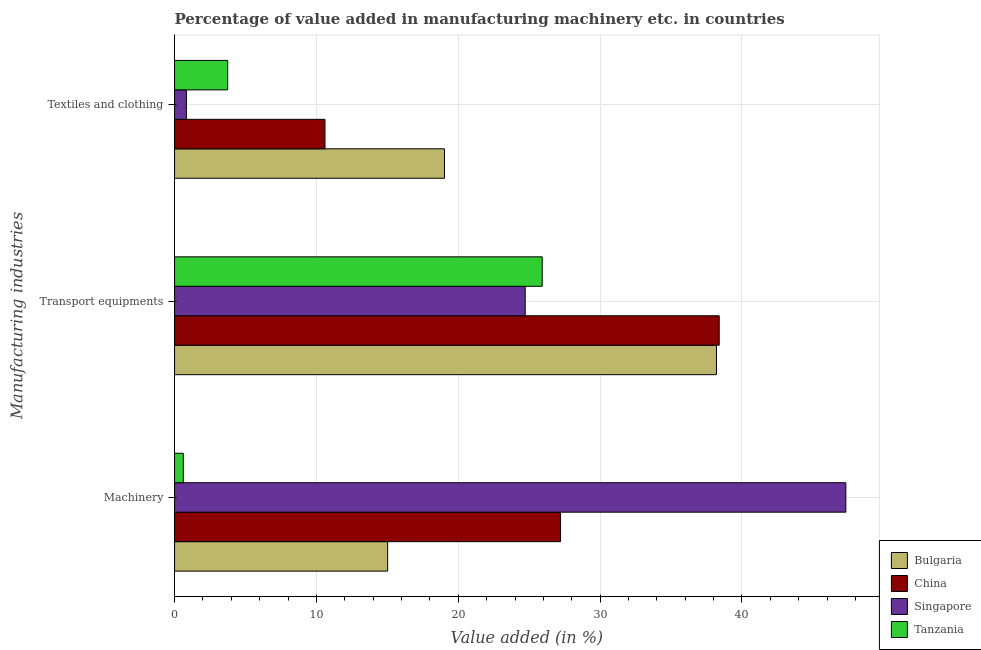How many different coloured bars are there?
Your response must be concise. 4. How many groups of bars are there?
Provide a succinct answer. 3. Are the number of bars per tick equal to the number of legend labels?
Provide a succinct answer. Yes. How many bars are there on the 2nd tick from the bottom?
Make the answer very short. 4. What is the label of the 1st group of bars from the top?
Make the answer very short. Textiles and clothing. What is the value added in manufacturing machinery in Singapore?
Your answer should be very brief. 47.32. Across all countries, what is the maximum value added in manufacturing machinery?
Give a very brief answer. 47.32. Across all countries, what is the minimum value added in manufacturing transport equipments?
Keep it short and to the point. 24.72. In which country was the value added in manufacturing machinery maximum?
Your response must be concise. Singapore. In which country was the value added in manufacturing transport equipments minimum?
Provide a succinct answer. Singapore. What is the total value added in manufacturing transport equipments in the graph?
Give a very brief answer. 127.24. What is the difference between the value added in manufacturing textile and clothing in Bulgaria and that in Singapore?
Offer a very short reply. 18.19. What is the difference between the value added in manufacturing transport equipments in China and the value added in manufacturing machinery in Singapore?
Provide a succinct answer. -8.93. What is the average value added in manufacturing machinery per country?
Provide a succinct answer. 22.54. What is the difference between the value added in manufacturing textile and clothing and value added in manufacturing machinery in Bulgaria?
Offer a terse response. 4.01. What is the ratio of the value added in manufacturing textile and clothing in Singapore to that in Tanzania?
Keep it short and to the point. 0.22. What is the difference between the highest and the second highest value added in manufacturing machinery?
Give a very brief answer. 20.11. What is the difference between the highest and the lowest value added in manufacturing transport equipments?
Ensure brevity in your answer.  13.68. In how many countries, is the value added in manufacturing textile and clothing greater than the average value added in manufacturing textile and clothing taken over all countries?
Make the answer very short. 2. What does the 1st bar from the top in Machinery represents?
Provide a short and direct response. Tanzania. What does the 3rd bar from the bottom in Textiles and clothing represents?
Ensure brevity in your answer.  Singapore. Is it the case that in every country, the sum of the value added in manufacturing machinery and value added in manufacturing transport equipments is greater than the value added in manufacturing textile and clothing?
Your answer should be compact. Yes. How many bars are there?
Make the answer very short. 12. How many countries are there in the graph?
Offer a terse response. 4. What is the difference between two consecutive major ticks on the X-axis?
Provide a succinct answer. 10. Are the values on the major ticks of X-axis written in scientific E-notation?
Ensure brevity in your answer.  No. Does the graph contain any zero values?
Offer a terse response. No. How are the legend labels stacked?
Offer a very short reply. Vertical. What is the title of the graph?
Offer a terse response. Percentage of value added in manufacturing machinery etc. in countries. What is the label or title of the X-axis?
Your response must be concise. Value added (in %). What is the label or title of the Y-axis?
Make the answer very short. Manufacturing industries. What is the Value added (in %) of Bulgaria in Machinery?
Offer a terse response. 15.02. What is the Value added (in %) of China in Machinery?
Your answer should be very brief. 27.21. What is the Value added (in %) of Singapore in Machinery?
Offer a very short reply. 47.32. What is the Value added (in %) in Tanzania in Machinery?
Make the answer very short. 0.62. What is the Value added (in %) of Bulgaria in Transport equipments?
Provide a succinct answer. 38.2. What is the Value added (in %) in China in Transport equipments?
Provide a succinct answer. 38.4. What is the Value added (in %) in Singapore in Transport equipments?
Keep it short and to the point. 24.72. What is the Value added (in %) in Tanzania in Transport equipments?
Offer a terse response. 25.92. What is the Value added (in %) of Bulgaria in Textiles and clothing?
Your response must be concise. 19.03. What is the Value added (in %) in China in Textiles and clothing?
Give a very brief answer. 10.6. What is the Value added (in %) in Singapore in Textiles and clothing?
Offer a very short reply. 0.84. What is the Value added (in %) of Tanzania in Textiles and clothing?
Offer a very short reply. 3.74. Across all Manufacturing industries, what is the maximum Value added (in %) of Bulgaria?
Provide a short and direct response. 38.2. Across all Manufacturing industries, what is the maximum Value added (in %) of China?
Offer a terse response. 38.4. Across all Manufacturing industries, what is the maximum Value added (in %) of Singapore?
Give a very brief answer. 47.32. Across all Manufacturing industries, what is the maximum Value added (in %) in Tanzania?
Give a very brief answer. 25.92. Across all Manufacturing industries, what is the minimum Value added (in %) of Bulgaria?
Offer a terse response. 15.02. Across all Manufacturing industries, what is the minimum Value added (in %) of China?
Provide a short and direct response. 10.6. Across all Manufacturing industries, what is the minimum Value added (in %) in Singapore?
Offer a terse response. 0.84. Across all Manufacturing industries, what is the minimum Value added (in %) of Tanzania?
Make the answer very short. 0.62. What is the total Value added (in %) in Bulgaria in the graph?
Your answer should be very brief. 72.25. What is the total Value added (in %) in China in the graph?
Keep it short and to the point. 76.21. What is the total Value added (in %) of Singapore in the graph?
Your answer should be very brief. 72.88. What is the total Value added (in %) of Tanzania in the graph?
Offer a terse response. 30.28. What is the difference between the Value added (in %) of Bulgaria in Machinery and that in Transport equipments?
Your answer should be very brief. -23.18. What is the difference between the Value added (in %) in China in Machinery and that in Transport equipments?
Your response must be concise. -11.18. What is the difference between the Value added (in %) of Singapore in Machinery and that in Transport equipments?
Make the answer very short. 22.6. What is the difference between the Value added (in %) of Tanzania in Machinery and that in Transport equipments?
Your answer should be compact. -25.3. What is the difference between the Value added (in %) of Bulgaria in Machinery and that in Textiles and clothing?
Keep it short and to the point. -4.01. What is the difference between the Value added (in %) of China in Machinery and that in Textiles and clothing?
Provide a succinct answer. 16.61. What is the difference between the Value added (in %) of Singapore in Machinery and that in Textiles and clothing?
Provide a short and direct response. 46.49. What is the difference between the Value added (in %) in Tanzania in Machinery and that in Textiles and clothing?
Your answer should be very brief. -3.13. What is the difference between the Value added (in %) of Bulgaria in Transport equipments and that in Textiles and clothing?
Keep it short and to the point. 19.17. What is the difference between the Value added (in %) in China in Transport equipments and that in Textiles and clothing?
Ensure brevity in your answer.  27.79. What is the difference between the Value added (in %) in Singapore in Transport equipments and that in Textiles and clothing?
Provide a succinct answer. 23.88. What is the difference between the Value added (in %) of Tanzania in Transport equipments and that in Textiles and clothing?
Make the answer very short. 22.17. What is the difference between the Value added (in %) of Bulgaria in Machinery and the Value added (in %) of China in Transport equipments?
Make the answer very short. -23.37. What is the difference between the Value added (in %) of Bulgaria in Machinery and the Value added (in %) of Singapore in Transport equipments?
Offer a terse response. -9.7. What is the difference between the Value added (in %) of Bulgaria in Machinery and the Value added (in %) of Tanzania in Transport equipments?
Ensure brevity in your answer.  -10.9. What is the difference between the Value added (in %) in China in Machinery and the Value added (in %) in Singapore in Transport equipments?
Your response must be concise. 2.49. What is the difference between the Value added (in %) of China in Machinery and the Value added (in %) of Tanzania in Transport equipments?
Provide a short and direct response. 1.29. What is the difference between the Value added (in %) of Singapore in Machinery and the Value added (in %) of Tanzania in Transport equipments?
Provide a short and direct response. 21.4. What is the difference between the Value added (in %) in Bulgaria in Machinery and the Value added (in %) in China in Textiles and clothing?
Offer a very short reply. 4.42. What is the difference between the Value added (in %) of Bulgaria in Machinery and the Value added (in %) of Singapore in Textiles and clothing?
Ensure brevity in your answer.  14.19. What is the difference between the Value added (in %) of Bulgaria in Machinery and the Value added (in %) of Tanzania in Textiles and clothing?
Keep it short and to the point. 11.28. What is the difference between the Value added (in %) of China in Machinery and the Value added (in %) of Singapore in Textiles and clothing?
Your answer should be compact. 26.38. What is the difference between the Value added (in %) in China in Machinery and the Value added (in %) in Tanzania in Textiles and clothing?
Your response must be concise. 23.47. What is the difference between the Value added (in %) in Singapore in Machinery and the Value added (in %) in Tanzania in Textiles and clothing?
Ensure brevity in your answer.  43.58. What is the difference between the Value added (in %) in Bulgaria in Transport equipments and the Value added (in %) in China in Textiles and clothing?
Give a very brief answer. 27.6. What is the difference between the Value added (in %) in Bulgaria in Transport equipments and the Value added (in %) in Singapore in Textiles and clothing?
Give a very brief answer. 37.37. What is the difference between the Value added (in %) of Bulgaria in Transport equipments and the Value added (in %) of Tanzania in Textiles and clothing?
Your response must be concise. 34.46. What is the difference between the Value added (in %) of China in Transport equipments and the Value added (in %) of Singapore in Textiles and clothing?
Make the answer very short. 37.56. What is the difference between the Value added (in %) of China in Transport equipments and the Value added (in %) of Tanzania in Textiles and clothing?
Provide a succinct answer. 34.65. What is the difference between the Value added (in %) in Singapore in Transport equipments and the Value added (in %) in Tanzania in Textiles and clothing?
Give a very brief answer. 20.98. What is the average Value added (in %) in Bulgaria per Manufacturing industries?
Give a very brief answer. 24.08. What is the average Value added (in %) in China per Manufacturing industries?
Provide a short and direct response. 25.4. What is the average Value added (in %) of Singapore per Manufacturing industries?
Give a very brief answer. 24.29. What is the average Value added (in %) in Tanzania per Manufacturing industries?
Your answer should be compact. 10.09. What is the difference between the Value added (in %) of Bulgaria and Value added (in %) of China in Machinery?
Give a very brief answer. -12.19. What is the difference between the Value added (in %) in Bulgaria and Value added (in %) in Singapore in Machinery?
Provide a short and direct response. -32.3. What is the difference between the Value added (in %) of Bulgaria and Value added (in %) of Tanzania in Machinery?
Make the answer very short. 14.41. What is the difference between the Value added (in %) of China and Value added (in %) of Singapore in Machinery?
Make the answer very short. -20.11. What is the difference between the Value added (in %) in China and Value added (in %) in Tanzania in Machinery?
Give a very brief answer. 26.59. What is the difference between the Value added (in %) in Singapore and Value added (in %) in Tanzania in Machinery?
Provide a succinct answer. 46.71. What is the difference between the Value added (in %) in Bulgaria and Value added (in %) in China in Transport equipments?
Your answer should be very brief. -0.19. What is the difference between the Value added (in %) in Bulgaria and Value added (in %) in Singapore in Transport equipments?
Your answer should be compact. 13.48. What is the difference between the Value added (in %) in Bulgaria and Value added (in %) in Tanzania in Transport equipments?
Ensure brevity in your answer.  12.28. What is the difference between the Value added (in %) of China and Value added (in %) of Singapore in Transport equipments?
Make the answer very short. 13.68. What is the difference between the Value added (in %) in China and Value added (in %) in Tanzania in Transport equipments?
Provide a short and direct response. 12.48. What is the difference between the Value added (in %) in Singapore and Value added (in %) in Tanzania in Transport equipments?
Ensure brevity in your answer.  -1.2. What is the difference between the Value added (in %) of Bulgaria and Value added (in %) of China in Textiles and clothing?
Make the answer very short. 8.42. What is the difference between the Value added (in %) of Bulgaria and Value added (in %) of Singapore in Textiles and clothing?
Ensure brevity in your answer.  18.19. What is the difference between the Value added (in %) in Bulgaria and Value added (in %) in Tanzania in Textiles and clothing?
Your answer should be very brief. 15.28. What is the difference between the Value added (in %) of China and Value added (in %) of Singapore in Textiles and clothing?
Ensure brevity in your answer.  9.77. What is the difference between the Value added (in %) of China and Value added (in %) of Tanzania in Textiles and clothing?
Keep it short and to the point. 6.86. What is the difference between the Value added (in %) in Singapore and Value added (in %) in Tanzania in Textiles and clothing?
Make the answer very short. -2.91. What is the ratio of the Value added (in %) in Bulgaria in Machinery to that in Transport equipments?
Your response must be concise. 0.39. What is the ratio of the Value added (in %) in China in Machinery to that in Transport equipments?
Your answer should be very brief. 0.71. What is the ratio of the Value added (in %) in Singapore in Machinery to that in Transport equipments?
Ensure brevity in your answer.  1.91. What is the ratio of the Value added (in %) in Tanzania in Machinery to that in Transport equipments?
Provide a succinct answer. 0.02. What is the ratio of the Value added (in %) of Bulgaria in Machinery to that in Textiles and clothing?
Your answer should be very brief. 0.79. What is the ratio of the Value added (in %) in China in Machinery to that in Textiles and clothing?
Your answer should be compact. 2.57. What is the ratio of the Value added (in %) of Singapore in Machinery to that in Textiles and clothing?
Your answer should be compact. 56.58. What is the ratio of the Value added (in %) in Tanzania in Machinery to that in Textiles and clothing?
Your response must be concise. 0.16. What is the ratio of the Value added (in %) of Bulgaria in Transport equipments to that in Textiles and clothing?
Your answer should be compact. 2.01. What is the ratio of the Value added (in %) of China in Transport equipments to that in Textiles and clothing?
Provide a short and direct response. 3.62. What is the ratio of the Value added (in %) of Singapore in Transport equipments to that in Textiles and clothing?
Offer a terse response. 29.56. What is the ratio of the Value added (in %) of Tanzania in Transport equipments to that in Textiles and clothing?
Your response must be concise. 6.92. What is the difference between the highest and the second highest Value added (in %) of Bulgaria?
Give a very brief answer. 19.17. What is the difference between the highest and the second highest Value added (in %) of China?
Provide a short and direct response. 11.18. What is the difference between the highest and the second highest Value added (in %) in Singapore?
Offer a terse response. 22.6. What is the difference between the highest and the second highest Value added (in %) in Tanzania?
Offer a terse response. 22.17. What is the difference between the highest and the lowest Value added (in %) in Bulgaria?
Your answer should be very brief. 23.18. What is the difference between the highest and the lowest Value added (in %) in China?
Provide a short and direct response. 27.79. What is the difference between the highest and the lowest Value added (in %) of Singapore?
Provide a succinct answer. 46.49. What is the difference between the highest and the lowest Value added (in %) in Tanzania?
Offer a terse response. 25.3. 